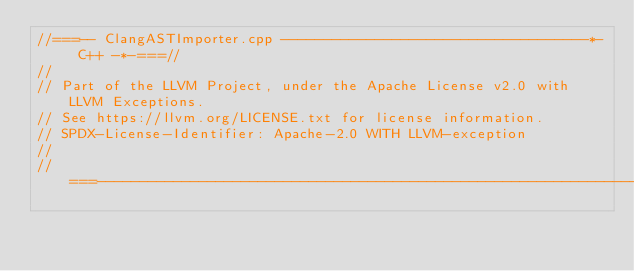<code> <loc_0><loc_0><loc_500><loc_500><_C++_>//===-- ClangASTImporter.cpp ------------------------------------*- C++ -*-===//
//
// Part of the LLVM Project, under the Apache License v2.0 with LLVM Exceptions.
// See https://llvm.org/LICENSE.txt for license information.
// SPDX-License-Identifier: Apache-2.0 WITH LLVM-exception
//
//===----------------------------------------------------------------------===//
</code> 